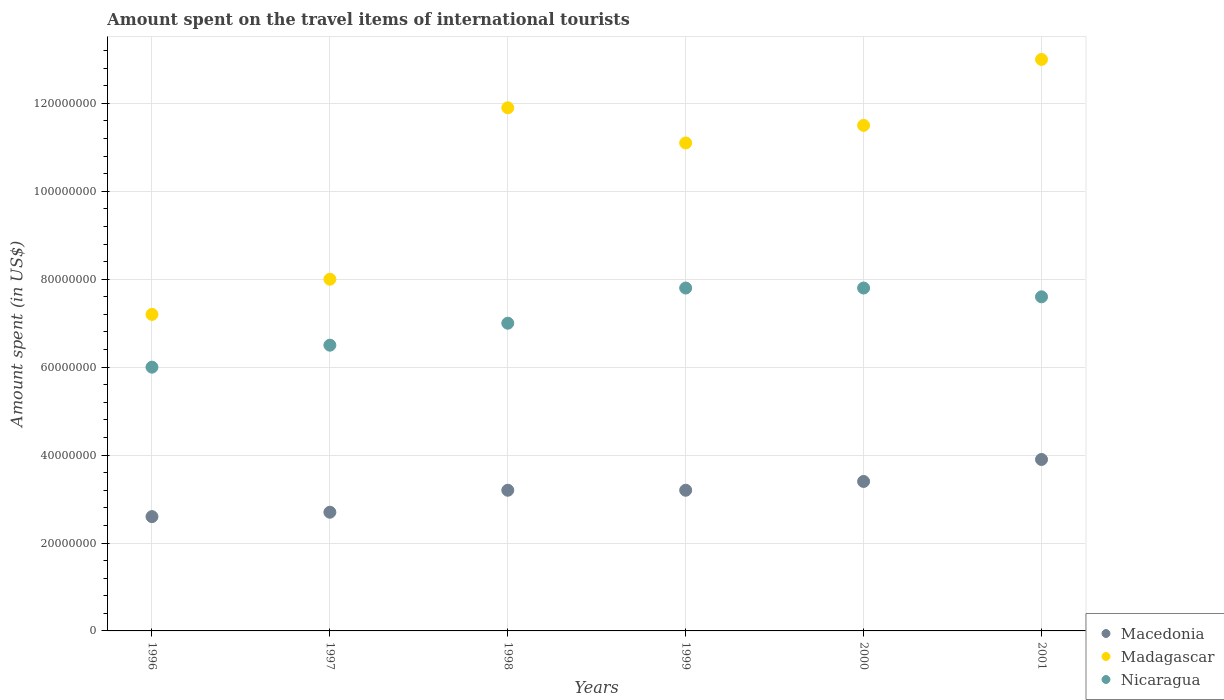How many different coloured dotlines are there?
Provide a short and direct response. 3. What is the amount spent on the travel items of international tourists in Nicaragua in 1997?
Your response must be concise. 6.50e+07. Across all years, what is the maximum amount spent on the travel items of international tourists in Nicaragua?
Provide a short and direct response. 7.80e+07. Across all years, what is the minimum amount spent on the travel items of international tourists in Macedonia?
Offer a very short reply. 2.60e+07. In which year was the amount spent on the travel items of international tourists in Nicaragua maximum?
Ensure brevity in your answer.  1999. In which year was the amount spent on the travel items of international tourists in Madagascar minimum?
Your answer should be very brief. 1996. What is the total amount spent on the travel items of international tourists in Nicaragua in the graph?
Keep it short and to the point. 4.27e+08. What is the difference between the amount spent on the travel items of international tourists in Madagascar in 1996 and that in 2001?
Your answer should be very brief. -5.80e+07. What is the difference between the amount spent on the travel items of international tourists in Nicaragua in 1998 and the amount spent on the travel items of international tourists in Macedonia in 2000?
Make the answer very short. 3.60e+07. What is the average amount spent on the travel items of international tourists in Madagascar per year?
Your response must be concise. 1.04e+08. In the year 2001, what is the difference between the amount spent on the travel items of international tourists in Macedonia and amount spent on the travel items of international tourists in Nicaragua?
Provide a short and direct response. -3.70e+07. What is the ratio of the amount spent on the travel items of international tourists in Macedonia in 1997 to that in 1999?
Your answer should be very brief. 0.84. What is the difference between the highest and the lowest amount spent on the travel items of international tourists in Macedonia?
Offer a very short reply. 1.30e+07. In how many years, is the amount spent on the travel items of international tourists in Madagascar greater than the average amount spent on the travel items of international tourists in Madagascar taken over all years?
Make the answer very short. 4. Is the sum of the amount spent on the travel items of international tourists in Nicaragua in 1998 and 2001 greater than the maximum amount spent on the travel items of international tourists in Madagascar across all years?
Offer a very short reply. Yes. Is it the case that in every year, the sum of the amount spent on the travel items of international tourists in Madagascar and amount spent on the travel items of international tourists in Nicaragua  is greater than the amount spent on the travel items of international tourists in Macedonia?
Your response must be concise. Yes. Does the amount spent on the travel items of international tourists in Macedonia monotonically increase over the years?
Offer a terse response. No. Is the amount spent on the travel items of international tourists in Madagascar strictly greater than the amount spent on the travel items of international tourists in Macedonia over the years?
Keep it short and to the point. Yes. Is the amount spent on the travel items of international tourists in Macedonia strictly less than the amount spent on the travel items of international tourists in Madagascar over the years?
Make the answer very short. Yes. How many dotlines are there?
Ensure brevity in your answer.  3. How many years are there in the graph?
Ensure brevity in your answer.  6. What is the difference between two consecutive major ticks on the Y-axis?
Make the answer very short. 2.00e+07. How many legend labels are there?
Your response must be concise. 3. How are the legend labels stacked?
Keep it short and to the point. Vertical. What is the title of the graph?
Your answer should be compact. Amount spent on the travel items of international tourists. Does "Czech Republic" appear as one of the legend labels in the graph?
Provide a succinct answer. No. What is the label or title of the X-axis?
Offer a very short reply. Years. What is the label or title of the Y-axis?
Your answer should be very brief. Amount spent (in US$). What is the Amount spent (in US$) of Macedonia in 1996?
Your answer should be very brief. 2.60e+07. What is the Amount spent (in US$) of Madagascar in 1996?
Your answer should be compact. 7.20e+07. What is the Amount spent (in US$) of Nicaragua in 1996?
Your answer should be very brief. 6.00e+07. What is the Amount spent (in US$) of Macedonia in 1997?
Your response must be concise. 2.70e+07. What is the Amount spent (in US$) of Madagascar in 1997?
Your answer should be compact. 8.00e+07. What is the Amount spent (in US$) in Nicaragua in 1997?
Make the answer very short. 6.50e+07. What is the Amount spent (in US$) of Macedonia in 1998?
Provide a short and direct response. 3.20e+07. What is the Amount spent (in US$) of Madagascar in 1998?
Offer a terse response. 1.19e+08. What is the Amount spent (in US$) of Nicaragua in 1998?
Your response must be concise. 7.00e+07. What is the Amount spent (in US$) in Macedonia in 1999?
Your answer should be very brief. 3.20e+07. What is the Amount spent (in US$) of Madagascar in 1999?
Keep it short and to the point. 1.11e+08. What is the Amount spent (in US$) of Nicaragua in 1999?
Provide a succinct answer. 7.80e+07. What is the Amount spent (in US$) in Macedonia in 2000?
Give a very brief answer. 3.40e+07. What is the Amount spent (in US$) in Madagascar in 2000?
Make the answer very short. 1.15e+08. What is the Amount spent (in US$) in Nicaragua in 2000?
Ensure brevity in your answer.  7.80e+07. What is the Amount spent (in US$) in Macedonia in 2001?
Your response must be concise. 3.90e+07. What is the Amount spent (in US$) in Madagascar in 2001?
Provide a succinct answer. 1.30e+08. What is the Amount spent (in US$) of Nicaragua in 2001?
Offer a terse response. 7.60e+07. Across all years, what is the maximum Amount spent (in US$) in Macedonia?
Provide a short and direct response. 3.90e+07. Across all years, what is the maximum Amount spent (in US$) of Madagascar?
Offer a terse response. 1.30e+08. Across all years, what is the maximum Amount spent (in US$) in Nicaragua?
Your answer should be compact. 7.80e+07. Across all years, what is the minimum Amount spent (in US$) of Macedonia?
Provide a short and direct response. 2.60e+07. Across all years, what is the minimum Amount spent (in US$) of Madagascar?
Make the answer very short. 7.20e+07. Across all years, what is the minimum Amount spent (in US$) in Nicaragua?
Offer a terse response. 6.00e+07. What is the total Amount spent (in US$) in Macedonia in the graph?
Offer a very short reply. 1.90e+08. What is the total Amount spent (in US$) in Madagascar in the graph?
Ensure brevity in your answer.  6.27e+08. What is the total Amount spent (in US$) of Nicaragua in the graph?
Ensure brevity in your answer.  4.27e+08. What is the difference between the Amount spent (in US$) in Madagascar in 1996 and that in 1997?
Keep it short and to the point. -8.00e+06. What is the difference between the Amount spent (in US$) of Nicaragua in 1996 and that in 1997?
Offer a very short reply. -5.00e+06. What is the difference between the Amount spent (in US$) of Macedonia in 1996 and that in 1998?
Provide a succinct answer. -6.00e+06. What is the difference between the Amount spent (in US$) in Madagascar in 1996 and that in 1998?
Offer a very short reply. -4.70e+07. What is the difference between the Amount spent (in US$) in Nicaragua in 1996 and that in 1998?
Provide a short and direct response. -1.00e+07. What is the difference between the Amount spent (in US$) in Macedonia in 1996 and that in 1999?
Provide a short and direct response. -6.00e+06. What is the difference between the Amount spent (in US$) in Madagascar in 1996 and that in 1999?
Keep it short and to the point. -3.90e+07. What is the difference between the Amount spent (in US$) of Nicaragua in 1996 and that in 1999?
Your response must be concise. -1.80e+07. What is the difference between the Amount spent (in US$) of Macedonia in 1996 and that in 2000?
Offer a very short reply. -8.00e+06. What is the difference between the Amount spent (in US$) of Madagascar in 1996 and that in 2000?
Offer a terse response. -4.30e+07. What is the difference between the Amount spent (in US$) in Nicaragua in 1996 and that in 2000?
Your answer should be very brief. -1.80e+07. What is the difference between the Amount spent (in US$) in Macedonia in 1996 and that in 2001?
Keep it short and to the point. -1.30e+07. What is the difference between the Amount spent (in US$) of Madagascar in 1996 and that in 2001?
Give a very brief answer. -5.80e+07. What is the difference between the Amount spent (in US$) in Nicaragua in 1996 and that in 2001?
Your answer should be compact. -1.60e+07. What is the difference between the Amount spent (in US$) of Macedonia in 1997 and that in 1998?
Your answer should be very brief. -5.00e+06. What is the difference between the Amount spent (in US$) in Madagascar in 1997 and that in 1998?
Keep it short and to the point. -3.90e+07. What is the difference between the Amount spent (in US$) in Nicaragua in 1997 and that in 1998?
Ensure brevity in your answer.  -5.00e+06. What is the difference between the Amount spent (in US$) of Macedonia in 1997 and that in 1999?
Your answer should be very brief. -5.00e+06. What is the difference between the Amount spent (in US$) of Madagascar in 1997 and that in 1999?
Ensure brevity in your answer.  -3.10e+07. What is the difference between the Amount spent (in US$) in Nicaragua in 1997 and that in 1999?
Your answer should be compact. -1.30e+07. What is the difference between the Amount spent (in US$) in Macedonia in 1997 and that in 2000?
Keep it short and to the point. -7.00e+06. What is the difference between the Amount spent (in US$) in Madagascar in 1997 and that in 2000?
Offer a terse response. -3.50e+07. What is the difference between the Amount spent (in US$) in Nicaragua in 1997 and that in 2000?
Offer a very short reply. -1.30e+07. What is the difference between the Amount spent (in US$) of Macedonia in 1997 and that in 2001?
Offer a terse response. -1.20e+07. What is the difference between the Amount spent (in US$) in Madagascar in 1997 and that in 2001?
Offer a terse response. -5.00e+07. What is the difference between the Amount spent (in US$) in Nicaragua in 1997 and that in 2001?
Provide a short and direct response. -1.10e+07. What is the difference between the Amount spent (in US$) of Macedonia in 1998 and that in 1999?
Your answer should be very brief. 0. What is the difference between the Amount spent (in US$) of Madagascar in 1998 and that in 1999?
Your answer should be very brief. 8.00e+06. What is the difference between the Amount spent (in US$) in Nicaragua in 1998 and that in 1999?
Keep it short and to the point. -8.00e+06. What is the difference between the Amount spent (in US$) of Macedonia in 1998 and that in 2000?
Provide a succinct answer. -2.00e+06. What is the difference between the Amount spent (in US$) of Nicaragua in 1998 and that in 2000?
Ensure brevity in your answer.  -8.00e+06. What is the difference between the Amount spent (in US$) in Macedonia in 1998 and that in 2001?
Make the answer very short. -7.00e+06. What is the difference between the Amount spent (in US$) in Madagascar in 1998 and that in 2001?
Give a very brief answer. -1.10e+07. What is the difference between the Amount spent (in US$) in Nicaragua in 1998 and that in 2001?
Provide a short and direct response. -6.00e+06. What is the difference between the Amount spent (in US$) of Macedonia in 1999 and that in 2000?
Give a very brief answer. -2.00e+06. What is the difference between the Amount spent (in US$) in Nicaragua in 1999 and that in 2000?
Make the answer very short. 0. What is the difference between the Amount spent (in US$) of Macedonia in 1999 and that in 2001?
Offer a terse response. -7.00e+06. What is the difference between the Amount spent (in US$) in Madagascar in 1999 and that in 2001?
Your answer should be very brief. -1.90e+07. What is the difference between the Amount spent (in US$) of Macedonia in 2000 and that in 2001?
Your response must be concise. -5.00e+06. What is the difference between the Amount spent (in US$) of Madagascar in 2000 and that in 2001?
Keep it short and to the point. -1.50e+07. What is the difference between the Amount spent (in US$) in Macedonia in 1996 and the Amount spent (in US$) in Madagascar in 1997?
Your answer should be very brief. -5.40e+07. What is the difference between the Amount spent (in US$) of Macedonia in 1996 and the Amount spent (in US$) of Nicaragua in 1997?
Your response must be concise. -3.90e+07. What is the difference between the Amount spent (in US$) of Madagascar in 1996 and the Amount spent (in US$) of Nicaragua in 1997?
Make the answer very short. 7.00e+06. What is the difference between the Amount spent (in US$) in Macedonia in 1996 and the Amount spent (in US$) in Madagascar in 1998?
Offer a terse response. -9.30e+07. What is the difference between the Amount spent (in US$) in Macedonia in 1996 and the Amount spent (in US$) in Nicaragua in 1998?
Provide a short and direct response. -4.40e+07. What is the difference between the Amount spent (in US$) in Madagascar in 1996 and the Amount spent (in US$) in Nicaragua in 1998?
Keep it short and to the point. 2.00e+06. What is the difference between the Amount spent (in US$) in Macedonia in 1996 and the Amount spent (in US$) in Madagascar in 1999?
Provide a succinct answer. -8.50e+07. What is the difference between the Amount spent (in US$) in Macedonia in 1996 and the Amount spent (in US$) in Nicaragua in 1999?
Offer a terse response. -5.20e+07. What is the difference between the Amount spent (in US$) of Madagascar in 1996 and the Amount spent (in US$) of Nicaragua in 1999?
Provide a succinct answer. -6.00e+06. What is the difference between the Amount spent (in US$) of Macedonia in 1996 and the Amount spent (in US$) of Madagascar in 2000?
Ensure brevity in your answer.  -8.90e+07. What is the difference between the Amount spent (in US$) in Macedonia in 1996 and the Amount spent (in US$) in Nicaragua in 2000?
Offer a terse response. -5.20e+07. What is the difference between the Amount spent (in US$) of Madagascar in 1996 and the Amount spent (in US$) of Nicaragua in 2000?
Provide a short and direct response. -6.00e+06. What is the difference between the Amount spent (in US$) in Macedonia in 1996 and the Amount spent (in US$) in Madagascar in 2001?
Keep it short and to the point. -1.04e+08. What is the difference between the Amount spent (in US$) in Macedonia in 1996 and the Amount spent (in US$) in Nicaragua in 2001?
Offer a terse response. -5.00e+07. What is the difference between the Amount spent (in US$) in Madagascar in 1996 and the Amount spent (in US$) in Nicaragua in 2001?
Provide a succinct answer. -4.00e+06. What is the difference between the Amount spent (in US$) in Macedonia in 1997 and the Amount spent (in US$) in Madagascar in 1998?
Make the answer very short. -9.20e+07. What is the difference between the Amount spent (in US$) in Macedonia in 1997 and the Amount spent (in US$) in Nicaragua in 1998?
Give a very brief answer. -4.30e+07. What is the difference between the Amount spent (in US$) of Madagascar in 1997 and the Amount spent (in US$) of Nicaragua in 1998?
Ensure brevity in your answer.  1.00e+07. What is the difference between the Amount spent (in US$) in Macedonia in 1997 and the Amount spent (in US$) in Madagascar in 1999?
Your answer should be very brief. -8.40e+07. What is the difference between the Amount spent (in US$) of Macedonia in 1997 and the Amount spent (in US$) of Nicaragua in 1999?
Keep it short and to the point. -5.10e+07. What is the difference between the Amount spent (in US$) of Madagascar in 1997 and the Amount spent (in US$) of Nicaragua in 1999?
Make the answer very short. 2.00e+06. What is the difference between the Amount spent (in US$) of Macedonia in 1997 and the Amount spent (in US$) of Madagascar in 2000?
Ensure brevity in your answer.  -8.80e+07. What is the difference between the Amount spent (in US$) of Macedonia in 1997 and the Amount spent (in US$) of Nicaragua in 2000?
Provide a short and direct response. -5.10e+07. What is the difference between the Amount spent (in US$) of Macedonia in 1997 and the Amount spent (in US$) of Madagascar in 2001?
Provide a short and direct response. -1.03e+08. What is the difference between the Amount spent (in US$) of Macedonia in 1997 and the Amount spent (in US$) of Nicaragua in 2001?
Your answer should be very brief. -4.90e+07. What is the difference between the Amount spent (in US$) in Macedonia in 1998 and the Amount spent (in US$) in Madagascar in 1999?
Make the answer very short. -7.90e+07. What is the difference between the Amount spent (in US$) in Macedonia in 1998 and the Amount spent (in US$) in Nicaragua in 1999?
Offer a terse response. -4.60e+07. What is the difference between the Amount spent (in US$) in Madagascar in 1998 and the Amount spent (in US$) in Nicaragua in 1999?
Offer a terse response. 4.10e+07. What is the difference between the Amount spent (in US$) of Macedonia in 1998 and the Amount spent (in US$) of Madagascar in 2000?
Keep it short and to the point. -8.30e+07. What is the difference between the Amount spent (in US$) in Macedonia in 1998 and the Amount spent (in US$) in Nicaragua in 2000?
Your answer should be compact. -4.60e+07. What is the difference between the Amount spent (in US$) in Madagascar in 1998 and the Amount spent (in US$) in Nicaragua in 2000?
Offer a terse response. 4.10e+07. What is the difference between the Amount spent (in US$) of Macedonia in 1998 and the Amount spent (in US$) of Madagascar in 2001?
Provide a short and direct response. -9.80e+07. What is the difference between the Amount spent (in US$) of Macedonia in 1998 and the Amount spent (in US$) of Nicaragua in 2001?
Keep it short and to the point. -4.40e+07. What is the difference between the Amount spent (in US$) in Madagascar in 1998 and the Amount spent (in US$) in Nicaragua in 2001?
Your answer should be compact. 4.30e+07. What is the difference between the Amount spent (in US$) of Macedonia in 1999 and the Amount spent (in US$) of Madagascar in 2000?
Your response must be concise. -8.30e+07. What is the difference between the Amount spent (in US$) of Macedonia in 1999 and the Amount spent (in US$) of Nicaragua in 2000?
Provide a short and direct response. -4.60e+07. What is the difference between the Amount spent (in US$) of Madagascar in 1999 and the Amount spent (in US$) of Nicaragua in 2000?
Offer a terse response. 3.30e+07. What is the difference between the Amount spent (in US$) of Macedonia in 1999 and the Amount spent (in US$) of Madagascar in 2001?
Give a very brief answer. -9.80e+07. What is the difference between the Amount spent (in US$) of Macedonia in 1999 and the Amount spent (in US$) of Nicaragua in 2001?
Give a very brief answer. -4.40e+07. What is the difference between the Amount spent (in US$) of Madagascar in 1999 and the Amount spent (in US$) of Nicaragua in 2001?
Offer a terse response. 3.50e+07. What is the difference between the Amount spent (in US$) of Macedonia in 2000 and the Amount spent (in US$) of Madagascar in 2001?
Provide a succinct answer. -9.60e+07. What is the difference between the Amount spent (in US$) of Macedonia in 2000 and the Amount spent (in US$) of Nicaragua in 2001?
Provide a succinct answer. -4.20e+07. What is the difference between the Amount spent (in US$) of Madagascar in 2000 and the Amount spent (in US$) of Nicaragua in 2001?
Offer a terse response. 3.90e+07. What is the average Amount spent (in US$) in Macedonia per year?
Keep it short and to the point. 3.17e+07. What is the average Amount spent (in US$) of Madagascar per year?
Provide a succinct answer. 1.04e+08. What is the average Amount spent (in US$) in Nicaragua per year?
Your answer should be very brief. 7.12e+07. In the year 1996, what is the difference between the Amount spent (in US$) in Macedonia and Amount spent (in US$) in Madagascar?
Give a very brief answer. -4.60e+07. In the year 1996, what is the difference between the Amount spent (in US$) in Macedonia and Amount spent (in US$) in Nicaragua?
Your answer should be compact. -3.40e+07. In the year 1996, what is the difference between the Amount spent (in US$) of Madagascar and Amount spent (in US$) of Nicaragua?
Ensure brevity in your answer.  1.20e+07. In the year 1997, what is the difference between the Amount spent (in US$) in Macedonia and Amount spent (in US$) in Madagascar?
Provide a short and direct response. -5.30e+07. In the year 1997, what is the difference between the Amount spent (in US$) of Macedonia and Amount spent (in US$) of Nicaragua?
Keep it short and to the point. -3.80e+07. In the year 1997, what is the difference between the Amount spent (in US$) of Madagascar and Amount spent (in US$) of Nicaragua?
Ensure brevity in your answer.  1.50e+07. In the year 1998, what is the difference between the Amount spent (in US$) of Macedonia and Amount spent (in US$) of Madagascar?
Your answer should be very brief. -8.70e+07. In the year 1998, what is the difference between the Amount spent (in US$) in Macedonia and Amount spent (in US$) in Nicaragua?
Give a very brief answer. -3.80e+07. In the year 1998, what is the difference between the Amount spent (in US$) of Madagascar and Amount spent (in US$) of Nicaragua?
Your answer should be compact. 4.90e+07. In the year 1999, what is the difference between the Amount spent (in US$) in Macedonia and Amount spent (in US$) in Madagascar?
Your response must be concise. -7.90e+07. In the year 1999, what is the difference between the Amount spent (in US$) in Macedonia and Amount spent (in US$) in Nicaragua?
Ensure brevity in your answer.  -4.60e+07. In the year 1999, what is the difference between the Amount spent (in US$) of Madagascar and Amount spent (in US$) of Nicaragua?
Your answer should be very brief. 3.30e+07. In the year 2000, what is the difference between the Amount spent (in US$) of Macedonia and Amount spent (in US$) of Madagascar?
Your answer should be very brief. -8.10e+07. In the year 2000, what is the difference between the Amount spent (in US$) in Macedonia and Amount spent (in US$) in Nicaragua?
Ensure brevity in your answer.  -4.40e+07. In the year 2000, what is the difference between the Amount spent (in US$) of Madagascar and Amount spent (in US$) of Nicaragua?
Give a very brief answer. 3.70e+07. In the year 2001, what is the difference between the Amount spent (in US$) of Macedonia and Amount spent (in US$) of Madagascar?
Keep it short and to the point. -9.10e+07. In the year 2001, what is the difference between the Amount spent (in US$) of Macedonia and Amount spent (in US$) of Nicaragua?
Your response must be concise. -3.70e+07. In the year 2001, what is the difference between the Amount spent (in US$) of Madagascar and Amount spent (in US$) of Nicaragua?
Your answer should be compact. 5.40e+07. What is the ratio of the Amount spent (in US$) of Macedonia in 1996 to that in 1997?
Your answer should be very brief. 0.96. What is the ratio of the Amount spent (in US$) of Madagascar in 1996 to that in 1997?
Make the answer very short. 0.9. What is the ratio of the Amount spent (in US$) in Nicaragua in 1996 to that in 1997?
Your answer should be very brief. 0.92. What is the ratio of the Amount spent (in US$) in Macedonia in 1996 to that in 1998?
Ensure brevity in your answer.  0.81. What is the ratio of the Amount spent (in US$) in Madagascar in 1996 to that in 1998?
Keep it short and to the point. 0.6. What is the ratio of the Amount spent (in US$) in Nicaragua in 1996 to that in 1998?
Your answer should be very brief. 0.86. What is the ratio of the Amount spent (in US$) of Macedonia in 1996 to that in 1999?
Provide a short and direct response. 0.81. What is the ratio of the Amount spent (in US$) in Madagascar in 1996 to that in 1999?
Your answer should be very brief. 0.65. What is the ratio of the Amount spent (in US$) of Nicaragua in 1996 to that in 1999?
Make the answer very short. 0.77. What is the ratio of the Amount spent (in US$) of Macedonia in 1996 to that in 2000?
Make the answer very short. 0.76. What is the ratio of the Amount spent (in US$) in Madagascar in 1996 to that in 2000?
Provide a succinct answer. 0.63. What is the ratio of the Amount spent (in US$) of Nicaragua in 1996 to that in 2000?
Offer a very short reply. 0.77. What is the ratio of the Amount spent (in US$) in Macedonia in 1996 to that in 2001?
Your answer should be compact. 0.67. What is the ratio of the Amount spent (in US$) in Madagascar in 1996 to that in 2001?
Your response must be concise. 0.55. What is the ratio of the Amount spent (in US$) of Nicaragua in 1996 to that in 2001?
Provide a succinct answer. 0.79. What is the ratio of the Amount spent (in US$) in Macedonia in 1997 to that in 1998?
Provide a short and direct response. 0.84. What is the ratio of the Amount spent (in US$) in Madagascar in 1997 to that in 1998?
Make the answer very short. 0.67. What is the ratio of the Amount spent (in US$) of Macedonia in 1997 to that in 1999?
Your answer should be compact. 0.84. What is the ratio of the Amount spent (in US$) in Madagascar in 1997 to that in 1999?
Your answer should be compact. 0.72. What is the ratio of the Amount spent (in US$) in Nicaragua in 1997 to that in 1999?
Give a very brief answer. 0.83. What is the ratio of the Amount spent (in US$) in Macedonia in 1997 to that in 2000?
Your response must be concise. 0.79. What is the ratio of the Amount spent (in US$) in Madagascar in 1997 to that in 2000?
Keep it short and to the point. 0.7. What is the ratio of the Amount spent (in US$) in Nicaragua in 1997 to that in 2000?
Give a very brief answer. 0.83. What is the ratio of the Amount spent (in US$) of Macedonia in 1997 to that in 2001?
Your response must be concise. 0.69. What is the ratio of the Amount spent (in US$) in Madagascar in 1997 to that in 2001?
Keep it short and to the point. 0.62. What is the ratio of the Amount spent (in US$) of Nicaragua in 1997 to that in 2001?
Your answer should be compact. 0.86. What is the ratio of the Amount spent (in US$) in Macedonia in 1998 to that in 1999?
Your response must be concise. 1. What is the ratio of the Amount spent (in US$) in Madagascar in 1998 to that in 1999?
Your answer should be compact. 1.07. What is the ratio of the Amount spent (in US$) of Nicaragua in 1998 to that in 1999?
Offer a very short reply. 0.9. What is the ratio of the Amount spent (in US$) of Macedonia in 1998 to that in 2000?
Your answer should be compact. 0.94. What is the ratio of the Amount spent (in US$) of Madagascar in 1998 to that in 2000?
Your response must be concise. 1.03. What is the ratio of the Amount spent (in US$) of Nicaragua in 1998 to that in 2000?
Make the answer very short. 0.9. What is the ratio of the Amount spent (in US$) of Macedonia in 1998 to that in 2001?
Ensure brevity in your answer.  0.82. What is the ratio of the Amount spent (in US$) of Madagascar in 1998 to that in 2001?
Make the answer very short. 0.92. What is the ratio of the Amount spent (in US$) of Nicaragua in 1998 to that in 2001?
Provide a short and direct response. 0.92. What is the ratio of the Amount spent (in US$) in Madagascar in 1999 to that in 2000?
Give a very brief answer. 0.97. What is the ratio of the Amount spent (in US$) of Macedonia in 1999 to that in 2001?
Provide a short and direct response. 0.82. What is the ratio of the Amount spent (in US$) in Madagascar in 1999 to that in 2001?
Keep it short and to the point. 0.85. What is the ratio of the Amount spent (in US$) in Nicaragua in 1999 to that in 2001?
Your answer should be compact. 1.03. What is the ratio of the Amount spent (in US$) of Macedonia in 2000 to that in 2001?
Your answer should be very brief. 0.87. What is the ratio of the Amount spent (in US$) in Madagascar in 2000 to that in 2001?
Offer a terse response. 0.88. What is the ratio of the Amount spent (in US$) in Nicaragua in 2000 to that in 2001?
Ensure brevity in your answer.  1.03. What is the difference between the highest and the second highest Amount spent (in US$) in Macedonia?
Provide a short and direct response. 5.00e+06. What is the difference between the highest and the second highest Amount spent (in US$) in Madagascar?
Offer a terse response. 1.10e+07. What is the difference between the highest and the second highest Amount spent (in US$) of Nicaragua?
Provide a succinct answer. 0. What is the difference between the highest and the lowest Amount spent (in US$) of Macedonia?
Ensure brevity in your answer.  1.30e+07. What is the difference between the highest and the lowest Amount spent (in US$) in Madagascar?
Give a very brief answer. 5.80e+07. What is the difference between the highest and the lowest Amount spent (in US$) in Nicaragua?
Offer a very short reply. 1.80e+07. 